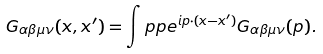<formula> <loc_0><loc_0><loc_500><loc_500>G _ { \alpha \beta \mu \nu } ( x , x ^ { \prime } ) = \int p { p } e ^ { i p \cdot ( x - x ^ { \prime } ) } G _ { \alpha \beta \mu \nu } ( p ) .</formula> 